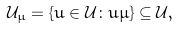<formula> <loc_0><loc_0><loc_500><loc_500>\mathcal { U } _ { \mu } = \{ u \in \mathcal { U } \colon u \mu \} \subseteq \mathcal { U } ,</formula> 